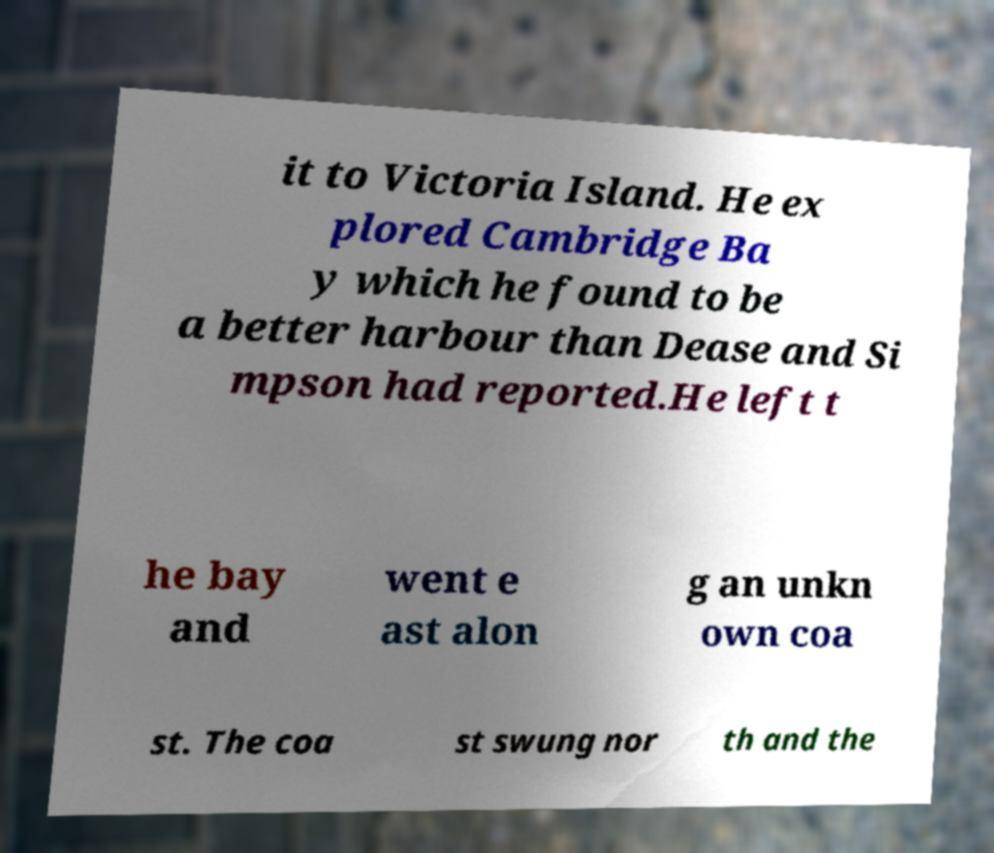Can you accurately transcribe the text from the provided image for me? it to Victoria Island. He ex plored Cambridge Ba y which he found to be a better harbour than Dease and Si mpson had reported.He left t he bay and went e ast alon g an unkn own coa st. The coa st swung nor th and the 